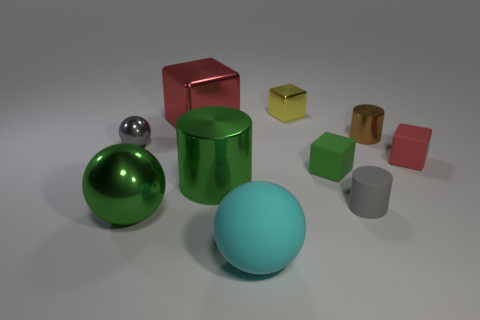Subtract all tiny spheres. How many spheres are left? 2 Subtract all cyan spheres. How many spheres are left? 2 Subtract 3 cubes. How many cubes are left? 1 Add 5 tiny red cubes. How many tiny red cubes exist? 6 Subtract 1 yellow blocks. How many objects are left? 9 Subtract all balls. How many objects are left? 7 Subtract all red spheres. Subtract all yellow cylinders. How many spheres are left? 3 Subtract all yellow spheres. How many red cubes are left? 2 Subtract all big things. Subtract all brown metal cylinders. How many objects are left? 5 Add 5 small brown cylinders. How many small brown cylinders are left? 6 